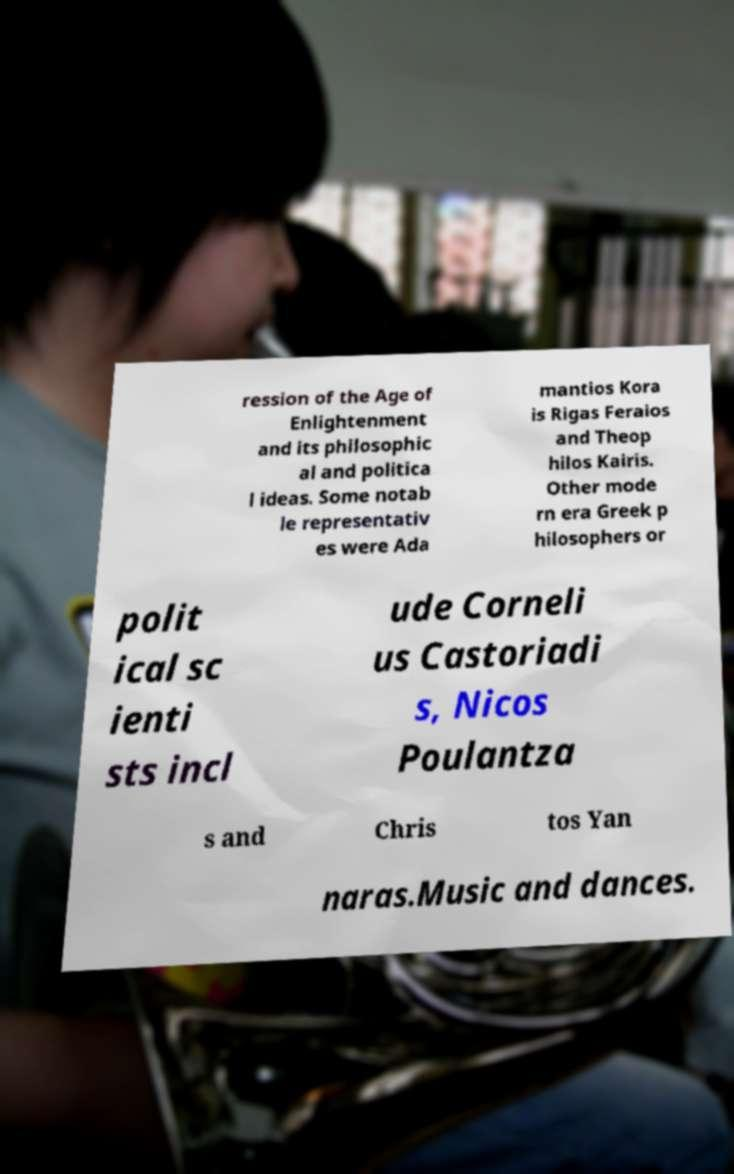Could you assist in decoding the text presented in this image and type it out clearly? ression of the Age of Enlightenment and its philosophic al and politica l ideas. Some notab le representativ es were Ada mantios Kora is Rigas Feraios and Theop hilos Kairis. Other mode rn era Greek p hilosophers or polit ical sc ienti sts incl ude Corneli us Castoriadi s, Nicos Poulantza s and Chris tos Yan naras.Music and dances. 